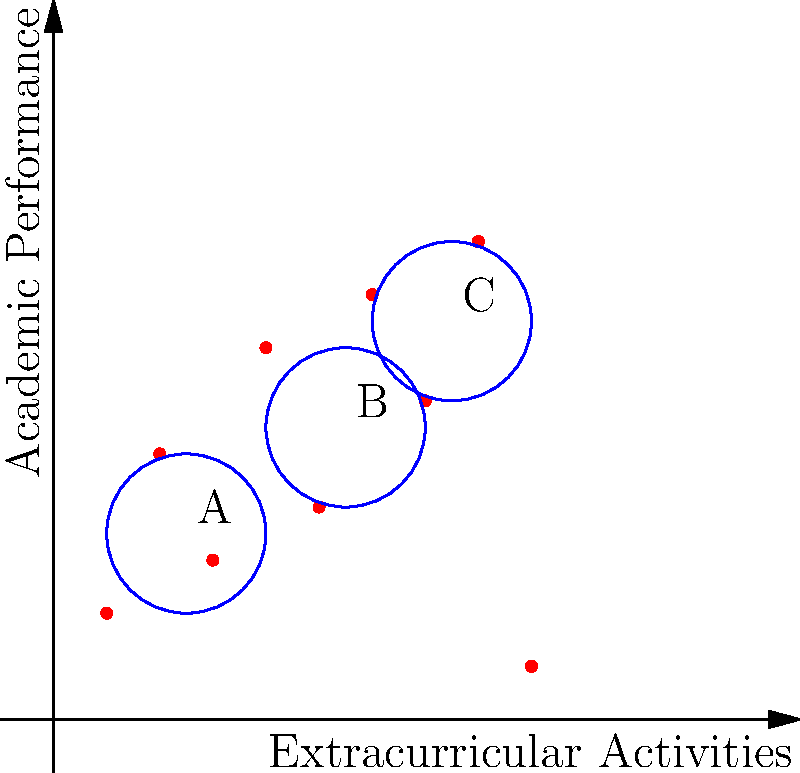As a high school teacher, you're analyzing student data to form study groups. The graph shows students plotted based on their extracurricular activities (x-axis) and academic performance (y-axis). Three clusters (A, B, and C) have been identified. Which cluster represents students with high academic performance but moderate extracurricular involvement? To answer this question, we need to analyze the three clusters in the graph:

1. Cluster A: Located in the bottom-left corner of the graph.
   - Low extracurricular activities (x-axis values around 1-4)
   - Low to moderate academic performance (y-axis values around 2-5)

2. Cluster B: Located in the middle of the graph.
   - Moderate extracurricular activities (x-axis values around 4-7)
   - Moderate academic performance (y-axis values around 4-7)

3. Cluster C: Located in the top-right corner of the graph.
   - High extracurricular activities (x-axis values around 6-9)
   - High academic performance (y-axis values around 6-9)

The question asks for students with high academic performance but moderate extracurricular involvement. This description best fits Cluster B:
- It has higher academic performance than Cluster A
- It has moderate extracurricular involvement compared to Cluster C
- Cluster C has both high academic performance and high extracurricular involvement, which doesn't match the description in the question

Therefore, Cluster B represents students with high academic performance but moderate extracurricular involvement.
Answer: Cluster B 